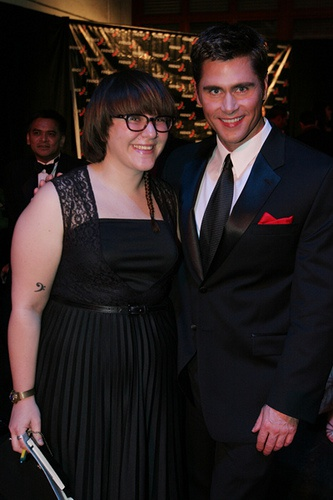Describe the objects in this image and their specific colors. I can see people in black, brown, and lightpink tones, people in black, brown, maroon, and lavender tones, people in black, maroon, gray, and darkgray tones, tie in black and gray tones, and tie in black, darkgray, and gray tones in this image. 